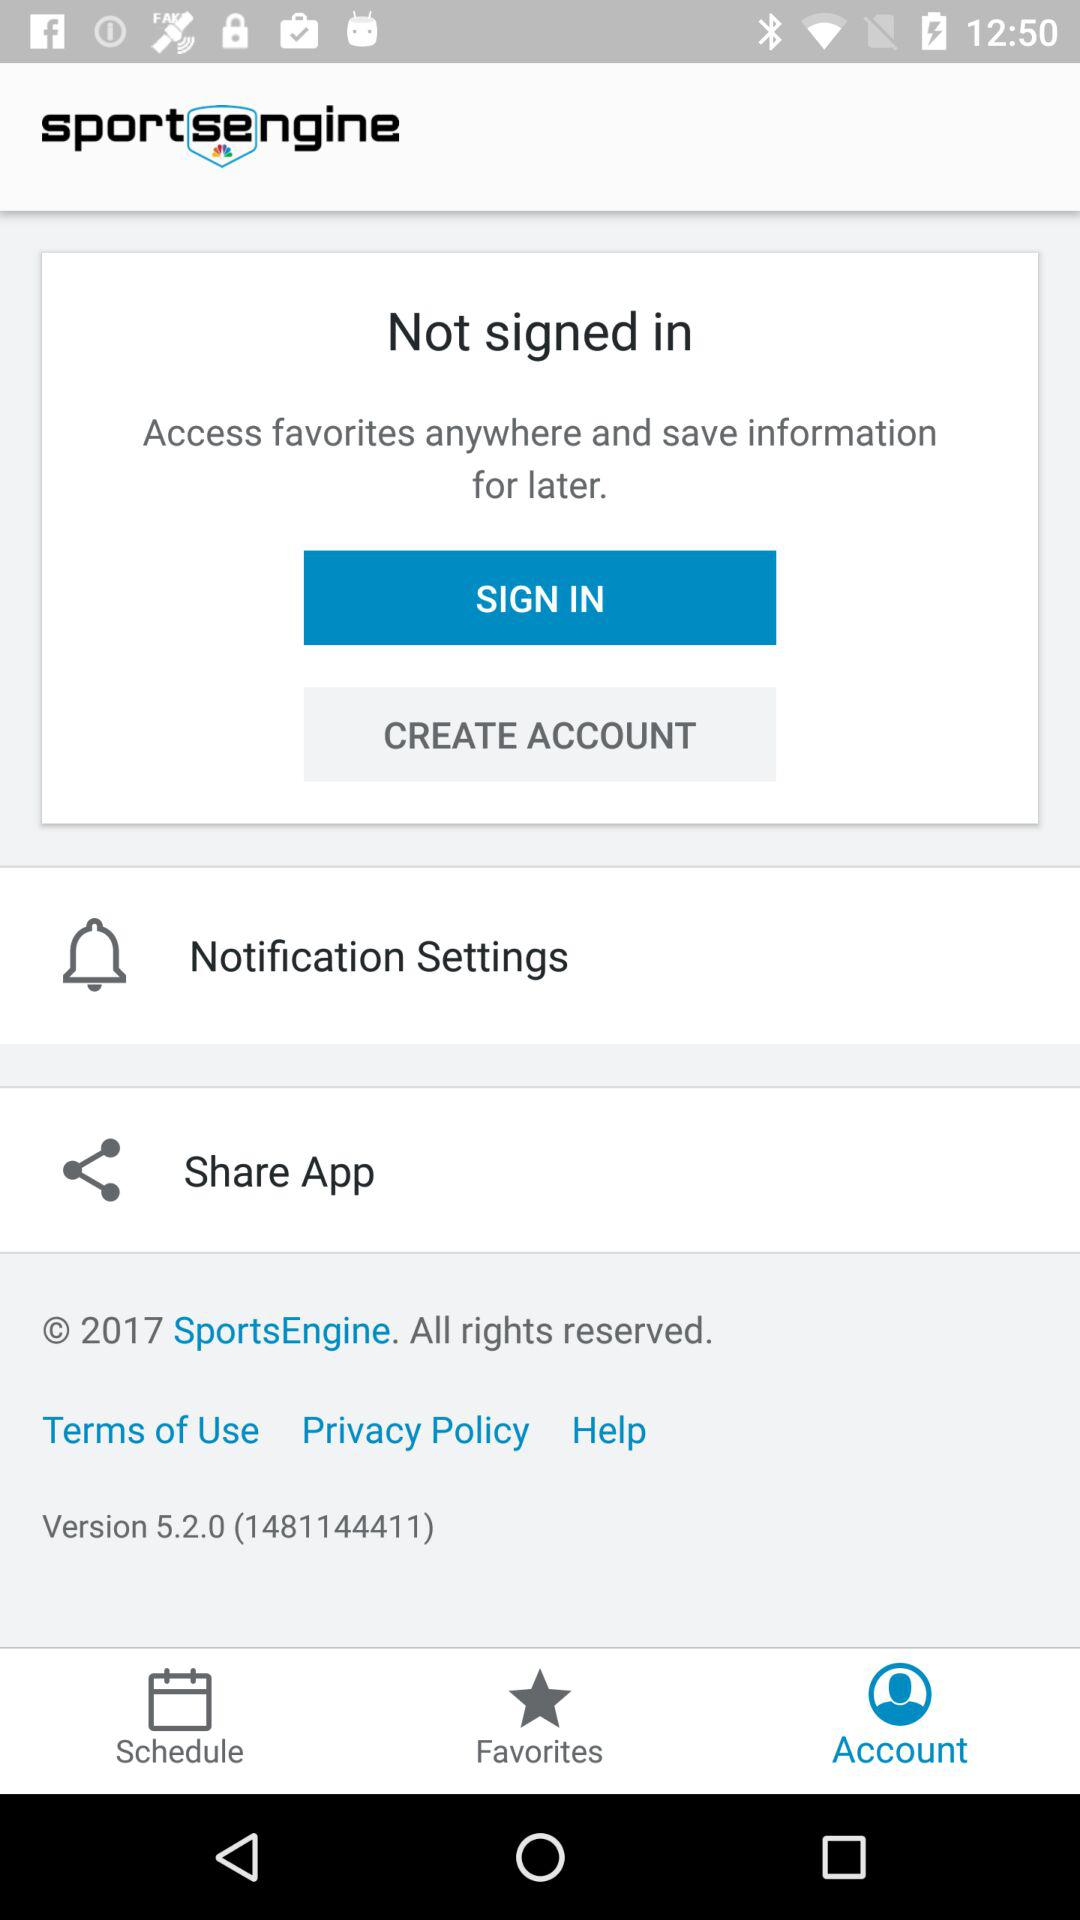What is the application name? The application name is "SportsEngine". 